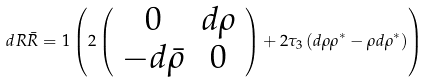Convert formula to latex. <formula><loc_0><loc_0><loc_500><loc_500>d R \bar { R } = { 1 } \left ( 2 \left ( \begin{array} { c c } 0 & d \rho \\ - d \bar { \rho } & 0 \end{array} \right ) + 2 \tau _ { 3 } \left ( d \rho \rho ^ { * } - \rho d \rho ^ { * } \right ) \right )</formula> 